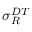Convert formula to latex. <formula><loc_0><loc_0><loc_500><loc_500>\sigma _ { R } ^ { D T }</formula> 